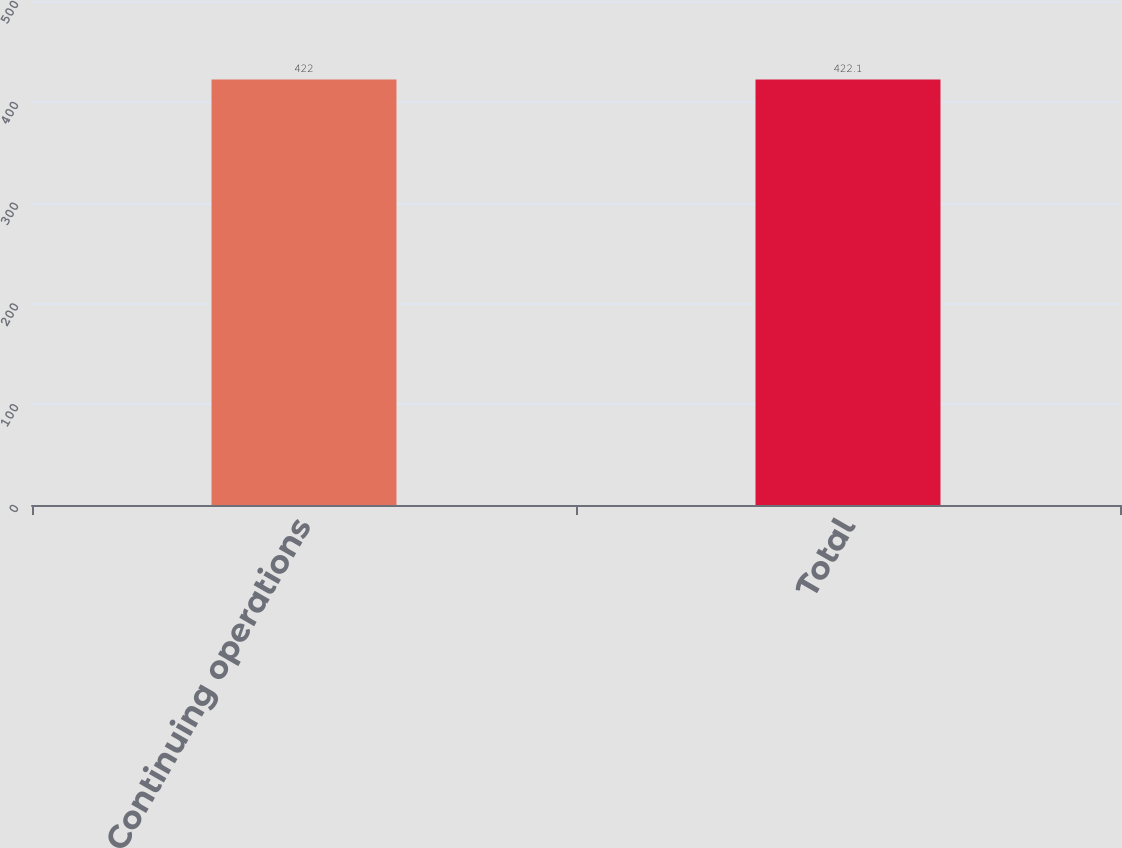<chart> <loc_0><loc_0><loc_500><loc_500><bar_chart><fcel>Continuing operations<fcel>Total<nl><fcel>422<fcel>422.1<nl></chart> 